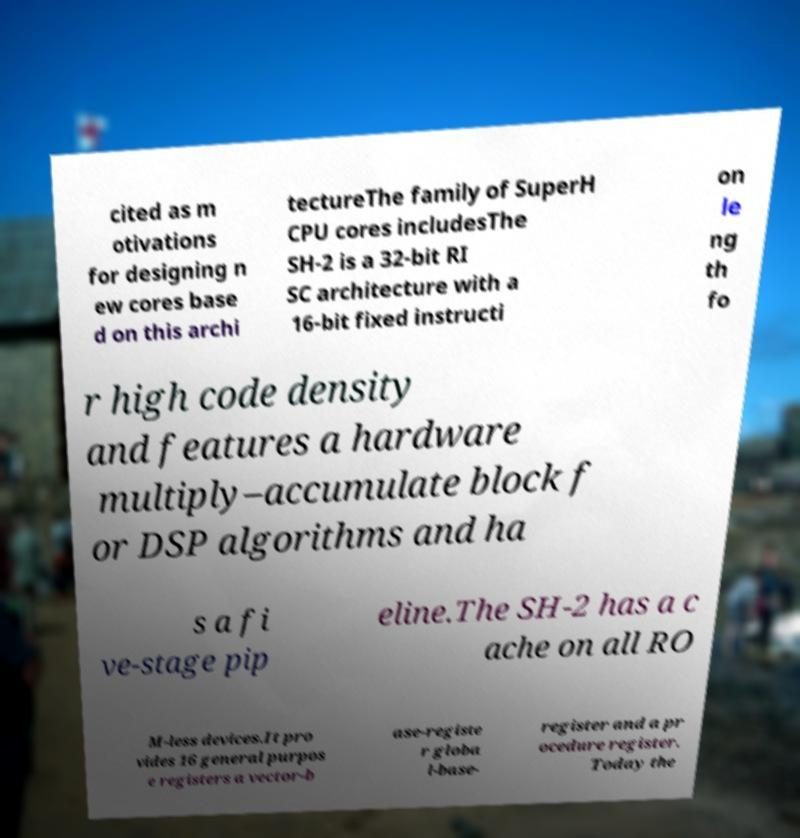Please read and relay the text visible in this image. What does it say? cited as m otivations for designing n ew cores base d on this archi tectureThe family of SuperH CPU cores includesThe SH-2 is a 32-bit RI SC architecture with a 16-bit fixed instructi on le ng th fo r high code density and features a hardware multiply–accumulate block f or DSP algorithms and ha s a fi ve-stage pip eline.The SH-2 has a c ache on all RO M-less devices.It pro vides 16 general purpos e registers a vector-b ase-registe r globa l-base- register and a pr ocedure register. Today the 